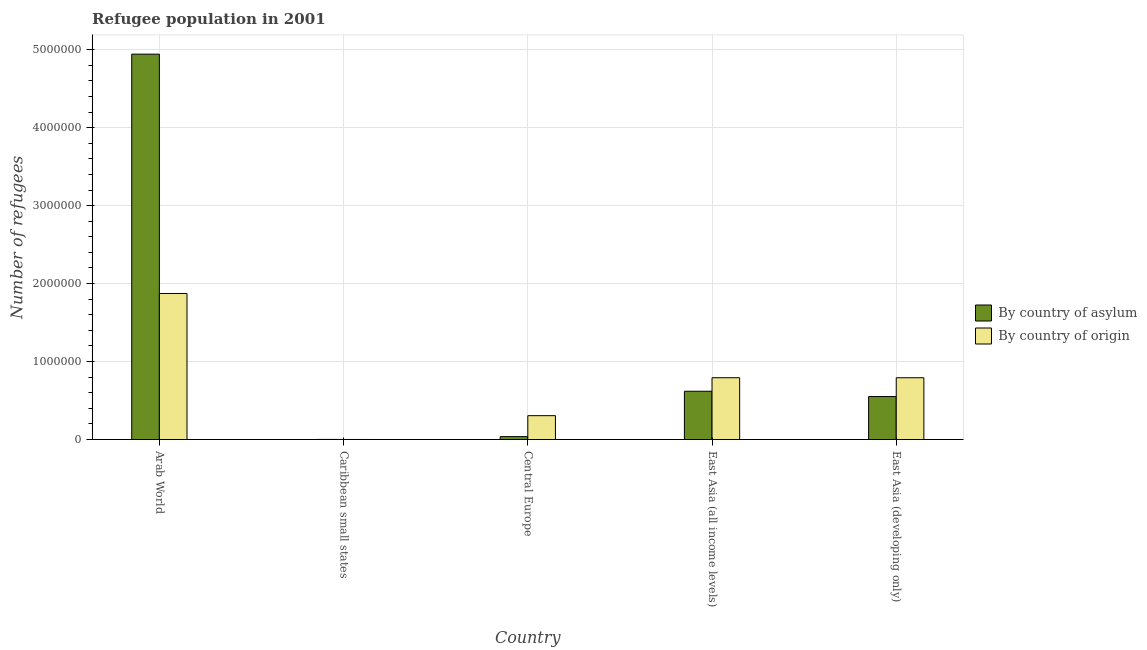How many different coloured bars are there?
Offer a very short reply. 2. What is the label of the 1st group of bars from the left?
Your answer should be compact. Arab World. What is the number of refugees by country of asylum in Arab World?
Your answer should be compact. 4.94e+06. Across all countries, what is the maximum number of refugees by country of origin?
Your answer should be very brief. 1.87e+06. Across all countries, what is the minimum number of refugees by country of origin?
Offer a very short reply. 471. In which country was the number of refugees by country of asylum maximum?
Your answer should be compact. Arab World. In which country was the number of refugees by country of origin minimum?
Give a very brief answer. Caribbean small states. What is the total number of refugees by country of origin in the graph?
Provide a short and direct response. 3.76e+06. What is the difference between the number of refugees by country of asylum in Arab World and that in Caribbean small states?
Give a very brief answer. 4.94e+06. What is the difference between the number of refugees by country of asylum in East Asia (developing only) and the number of refugees by country of origin in East Asia (all income levels)?
Your response must be concise. -2.41e+05. What is the average number of refugees by country of asylum per country?
Keep it short and to the point. 1.23e+06. What is the difference between the number of refugees by country of origin and number of refugees by country of asylum in Central Europe?
Ensure brevity in your answer.  2.69e+05. In how many countries, is the number of refugees by country of asylum greater than 2000000 ?
Ensure brevity in your answer.  1. What is the ratio of the number of refugees by country of asylum in Caribbean small states to that in East Asia (developing only)?
Offer a very short reply. 0. Is the number of refugees by country of origin in Arab World less than that in East Asia (developing only)?
Ensure brevity in your answer.  No. What is the difference between the highest and the second highest number of refugees by country of asylum?
Ensure brevity in your answer.  4.32e+06. What is the difference between the highest and the lowest number of refugees by country of asylum?
Offer a very short reply. 4.94e+06. Is the sum of the number of refugees by country of asylum in Arab World and East Asia (developing only) greater than the maximum number of refugees by country of origin across all countries?
Make the answer very short. Yes. What does the 2nd bar from the left in Caribbean small states represents?
Offer a terse response. By country of origin. What does the 1st bar from the right in Caribbean small states represents?
Ensure brevity in your answer.  By country of origin. How many bars are there?
Your answer should be compact. 10. Are the values on the major ticks of Y-axis written in scientific E-notation?
Your answer should be very brief. No. Does the graph contain any zero values?
Offer a very short reply. No. Does the graph contain grids?
Your answer should be compact. Yes. Where does the legend appear in the graph?
Give a very brief answer. Center right. What is the title of the graph?
Offer a terse response. Refugee population in 2001. What is the label or title of the Y-axis?
Provide a short and direct response. Number of refugees. What is the Number of refugees of By country of asylum in Arab World?
Provide a short and direct response. 4.94e+06. What is the Number of refugees of By country of origin in Arab World?
Your answer should be compact. 1.87e+06. What is the Number of refugees of By country of asylum in Caribbean small states?
Provide a short and direct response. 1129. What is the Number of refugees of By country of origin in Caribbean small states?
Provide a succinct answer. 471. What is the Number of refugees of By country of asylum in Central Europe?
Your answer should be compact. 3.71e+04. What is the Number of refugees in By country of origin in Central Europe?
Your answer should be compact. 3.06e+05. What is the Number of refugees of By country of asylum in East Asia (all income levels)?
Ensure brevity in your answer.  6.19e+05. What is the Number of refugees of By country of origin in East Asia (all income levels)?
Offer a terse response. 7.93e+05. What is the Number of refugees in By country of asylum in East Asia (developing only)?
Give a very brief answer. 5.51e+05. What is the Number of refugees of By country of origin in East Asia (developing only)?
Keep it short and to the point. 7.92e+05. Across all countries, what is the maximum Number of refugees in By country of asylum?
Offer a very short reply. 4.94e+06. Across all countries, what is the maximum Number of refugees in By country of origin?
Provide a succinct answer. 1.87e+06. Across all countries, what is the minimum Number of refugees in By country of asylum?
Offer a terse response. 1129. Across all countries, what is the minimum Number of refugees of By country of origin?
Your answer should be very brief. 471. What is the total Number of refugees of By country of asylum in the graph?
Keep it short and to the point. 6.15e+06. What is the total Number of refugees of By country of origin in the graph?
Keep it short and to the point. 3.76e+06. What is the difference between the Number of refugees of By country of asylum in Arab World and that in Caribbean small states?
Make the answer very short. 4.94e+06. What is the difference between the Number of refugees of By country of origin in Arab World and that in Caribbean small states?
Your response must be concise. 1.87e+06. What is the difference between the Number of refugees in By country of asylum in Arab World and that in Central Europe?
Make the answer very short. 4.91e+06. What is the difference between the Number of refugees of By country of origin in Arab World and that in Central Europe?
Provide a short and direct response. 1.57e+06. What is the difference between the Number of refugees of By country of asylum in Arab World and that in East Asia (all income levels)?
Offer a terse response. 4.32e+06. What is the difference between the Number of refugees in By country of origin in Arab World and that in East Asia (all income levels)?
Your answer should be very brief. 1.08e+06. What is the difference between the Number of refugees in By country of asylum in Arab World and that in East Asia (developing only)?
Keep it short and to the point. 4.39e+06. What is the difference between the Number of refugees of By country of origin in Arab World and that in East Asia (developing only)?
Your answer should be very brief. 1.08e+06. What is the difference between the Number of refugees in By country of asylum in Caribbean small states and that in Central Europe?
Make the answer very short. -3.60e+04. What is the difference between the Number of refugees of By country of origin in Caribbean small states and that in Central Europe?
Offer a very short reply. -3.06e+05. What is the difference between the Number of refugees of By country of asylum in Caribbean small states and that in East Asia (all income levels)?
Your answer should be very brief. -6.18e+05. What is the difference between the Number of refugees in By country of origin in Caribbean small states and that in East Asia (all income levels)?
Keep it short and to the point. -7.92e+05. What is the difference between the Number of refugees of By country of asylum in Caribbean small states and that in East Asia (developing only)?
Keep it short and to the point. -5.50e+05. What is the difference between the Number of refugees in By country of origin in Caribbean small states and that in East Asia (developing only)?
Offer a very short reply. -7.92e+05. What is the difference between the Number of refugees in By country of asylum in Central Europe and that in East Asia (all income levels)?
Make the answer very short. -5.82e+05. What is the difference between the Number of refugees of By country of origin in Central Europe and that in East Asia (all income levels)?
Your answer should be compact. -4.86e+05. What is the difference between the Number of refugees in By country of asylum in Central Europe and that in East Asia (developing only)?
Give a very brief answer. -5.14e+05. What is the difference between the Number of refugees in By country of origin in Central Europe and that in East Asia (developing only)?
Offer a terse response. -4.86e+05. What is the difference between the Number of refugees in By country of asylum in East Asia (all income levels) and that in East Asia (developing only)?
Give a very brief answer. 6.78e+04. What is the difference between the Number of refugees in By country of origin in East Asia (all income levels) and that in East Asia (developing only)?
Ensure brevity in your answer.  120. What is the difference between the Number of refugees in By country of asylum in Arab World and the Number of refugees in By country of origin in Caribbean small states?
Your answer should be very brief. 4.94e+06. What is the difference between the Number of refugees of By country of asylum in Arab World and the Number of refugees of By country of origin in Central Europe?
Keep it short and to the point. 4.64e+06. What is the difference between the Number of refugees in By country of asylum in Arab World and the Number of refugees in By country of origin in East Asia (all income levels)?
Offer a very short reply. 4.15e+06. What is the difference between the Number of refugees of By country of asylum in Arab World and the Number of refugees of By country of origin in East Asia (developing only)?
Provide a succinct answer. 4.15e+06. What is the difference between the Number of refugees of By country of asylum in Caribbean small states and the Number of refugees of By country of origin in Central Europe?
Keep it short and to the point. -3.05e+05. What is the difference between the Number of refugees of By country of asylum in Caribbean small states and the Number of refugees of By country of origin in East Asia (all income levels)?
Offer a terse response. -7.91e+05. What is the difference between the Number of refugees of By country of asylum in Caribbean small states and the Number of refugees of By country of origin in East Asia (developing only)?
Ensure brevity in your answer.  -7.91e+05. What is the difference between the Number of refugees of By country of asylum in Central Europe and the Number of refugees of By country of origin in East Asia (all income levels)?
Ensure brevity in your answer.  -7.55e+05. What is the difference between the Number of refugees in By country of asylum in Central Europe and the Number of refugees in By country of origin in East Asia (developing only)?
Your response must be concise. -7.55e+05. What is the difference between the Number of refugees of By country of asylum in East Asia (all income levels) and the Number of refugees of By country of origin in East Asia (developing only)?
Your answer should be very brief. -1.74e+05. What is the average Number of refugees in By country of asylum per country?
Your answer should be very brief. 1.23e+06. What is the average Number of refugees of By country of origin per country?
Offer a terse response. 7.53e+05. What is the difference between the Number of refugees of By country of asylum and Number of refugees of By country of origin in Arab World?
Provide a short and direct response. 3.07e+06. What is the difference between the Number of refugees in By country of asylum and Number of refugees in By country of origin in Caribbean small states?
Ensure brevity in your answer.  658. What is the difference between the Number of refugees in By country of asylum and Number of refugees in By country of origin in Central Europe?
Make the answer very short. -2.69e+05. What is the difference between the Number of refugees in By country of asylum and Number of refugees in By country of origin in East Asia (all income levels)?
Provide a succinct answer. -1.74e+05. What is the difference between the Number of refugees in By country of asylum and Number of refugees in By country of origin in East Asia (developing only)?
Give a very brief answer. -2.41e+05. What is the ratio of the Number of refugees in By country of asylum in Arab World to that in Caribbean small states?
Your answer should be compact. 4377.89. What is the ratio of the Number of refugees in By country of origin in Arab World to that in Caribbean small states?
Provide a short and direct response. 3976.66. What is the ratio of the Number of refugees of By country of asylum in Arab World to that in Central Europe?
Make the answer very short. 133.19. What is the ratio of the Number of refugees in By country of origin in Arab World to that in Central Europe?
Give a very brief answer. 6.12. What is the ratio of the Number of refugees of By country of asylum in Arab World to that in East Asia (all income levels)?
Your answer should be very brief. 7.99. What is the ratio of the Number of refugees in By country of origin in Arab World to that in East Asia (all income levels)?
Offer a terse response. 2.36. What is the ratio of the Number of refugees of By country of asylum in Arab World to that in East Asia (developing only)?
Ensure brevity in your answer.  8.97. What is the ratio of the Number of refugees in By country of origin in Arab World to that in East Asia (developing only)?
Your answer should be compact. 2.36. What is the ratio of the Number of refugees of By country of asylum in Caribbean small states to that in Central Europe?
Provide a succinct answer. 0.03. What is the ratio of the Number of refugees of By country of origin in Caribbean small states to that in Central Europe?
Keep it short and to the point. 0. What is the ratio of the Number of refugees in By country of asylum in Caribbean small states to that in East Asia (all income levels)?
Keep it short and to the point. 0. What is the ratio of the Number of refugees of By country of origin in Caribbean small states to that in East Asia (all income levels)?
Make the answer very short. 0. What is the ratio of the Number of refugees in By country of asylum in Caribbean small states to that in East Asia (developing only)?
Offer a very short reply. 0. What is the ratio of the Number of refugees of By country of origin in Caribbean small states to that in East Asia (developing only)?
Ensure brevity in your answer.  0. What is the ratio of the Number of refugees of By country of asylum in Central Europe to that in East Asia (all income levels)?
Your response must be concise. 0.06. What is the ratio of the Number of refugees of By country of origin in Central Europe to that in East Asia (all income levels)?
Give a very brief answer. 0.39. What is the ratio of the Number of refugees of By country of asylum in Central Europe to that in East Asia (developing only)?
Your response must be concise. 0.07. What is the ratio of the Number of refugees of By country of origin in Central Europe to that in East Asia (developing only)?
Make the answer very short. 0.39. What is the ratio of the Number of refugees in By country of asylum in East Asia (all income levels) to that in East Asia (developing only)?
Keep it short and to the point. 1.12. What is the difference between the highest and the second highest Number of refugees in By country of asylum?
Give a very brief answer. 4.32e+06. What is the difference between the highest and the second highest Number of refugees of By country of origin?
Offer a terse response. 1.08e+06. What is the difference between the highest and the lowest Number of refugees in By country of asylum?
Your response must be concise. 4.94e+06. What is the difference between the highest and the lowest Number of refugees in By country of origin?
Provide a short and direct response. 1.87e+06. 